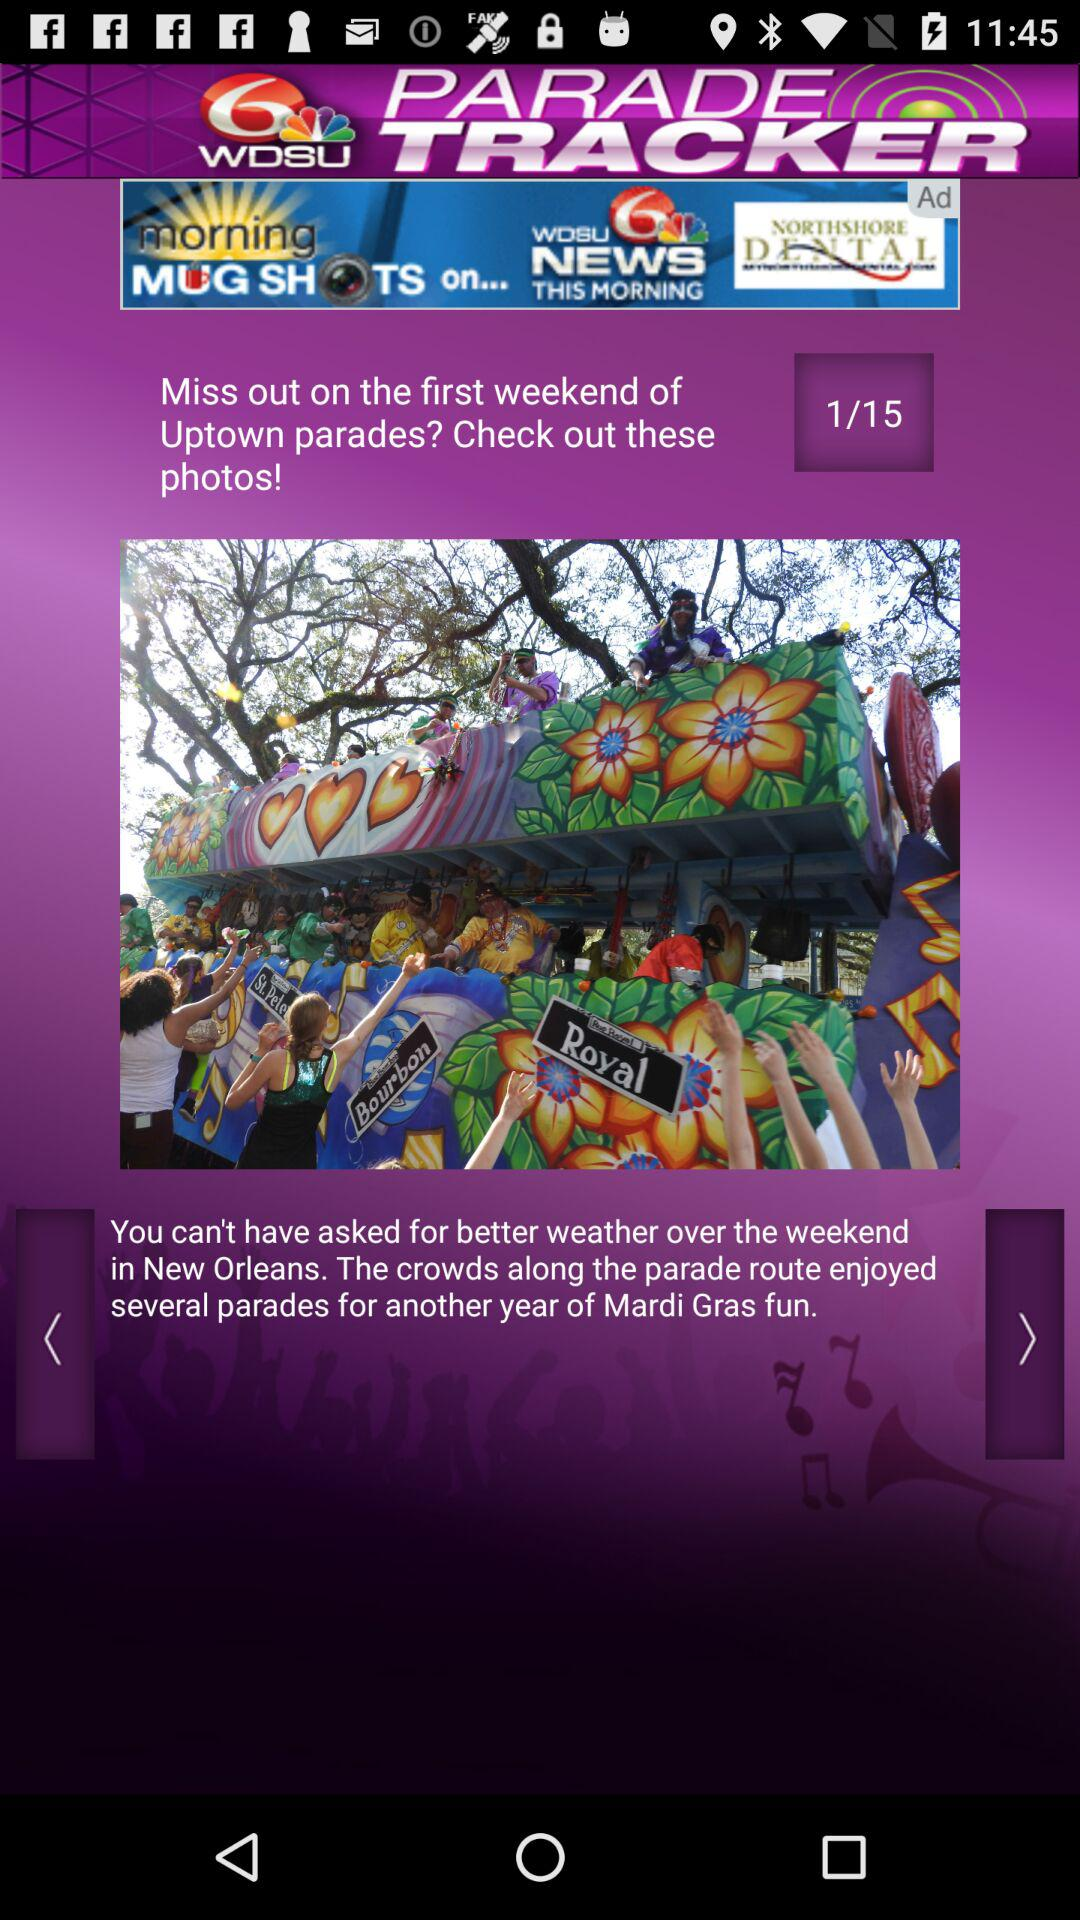What's the application name? The application name is "WDSU Parade Tracker". 